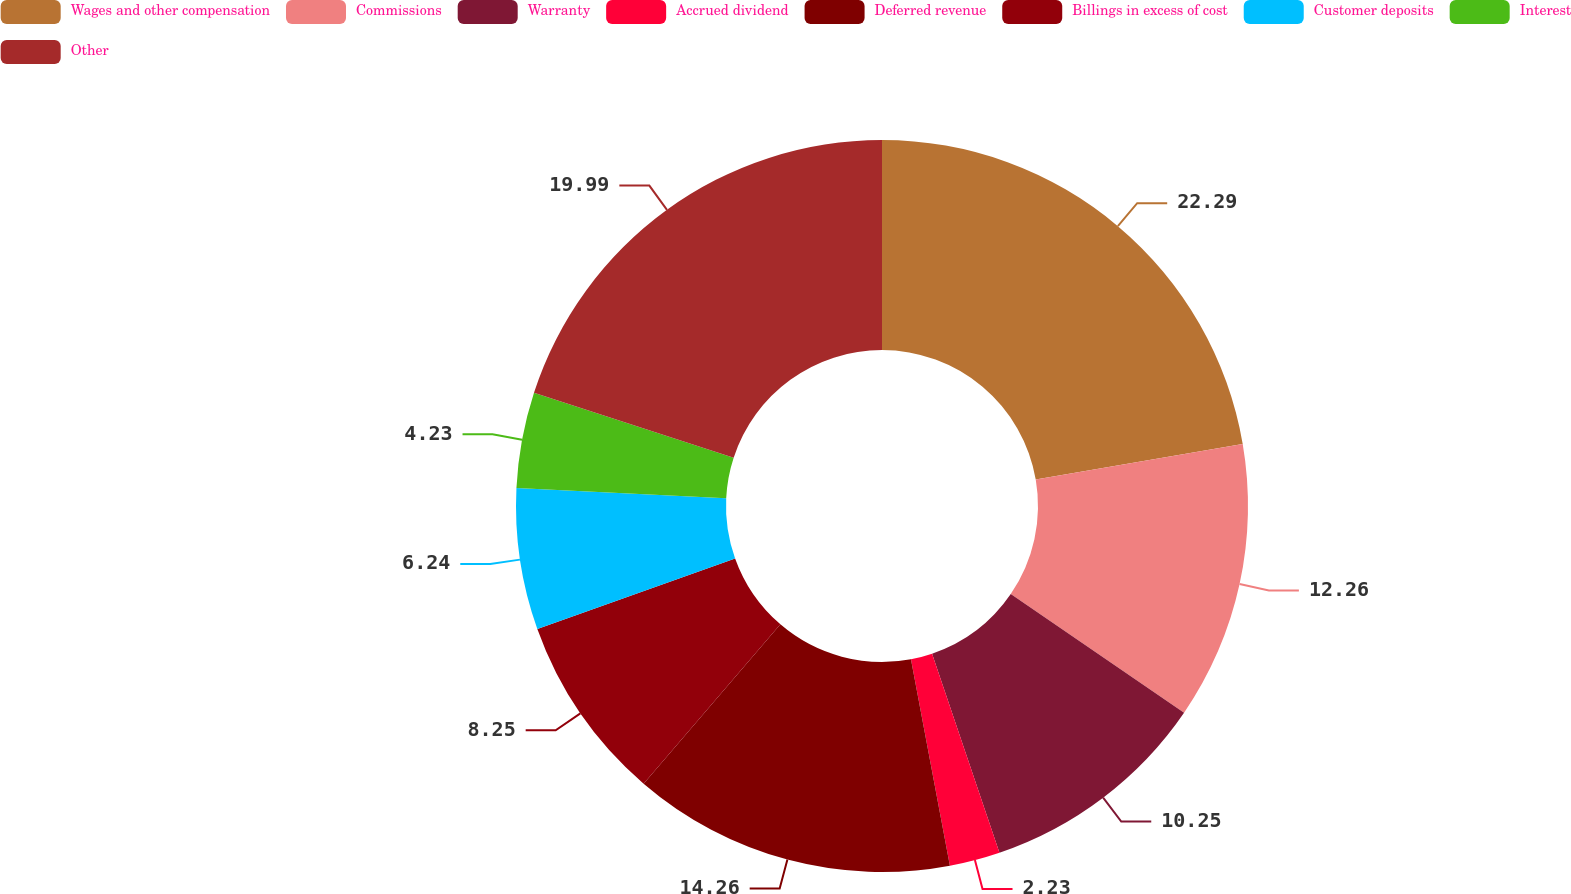Convert chart. <chart><loc_0><loc_0><loc_500><loc_500><pie_chart><fcel>Wages and other compensation<fcel>Commissions<fcel>Warranty<fcel>Accrued dividend<fcel>Deferred revenue<fcel>Billings in excess of cost<fcel>Customer deposits<fcel>Interest<fcel>Other<nl><fcel>22.29%<fcel>12.26%<fcel>10.25%<fcel>2.23%<fcel>14.26%<fcel>8.25%<fcel>6.24%<fcel>4.23%<fcel>19.99%<nl></chart> 